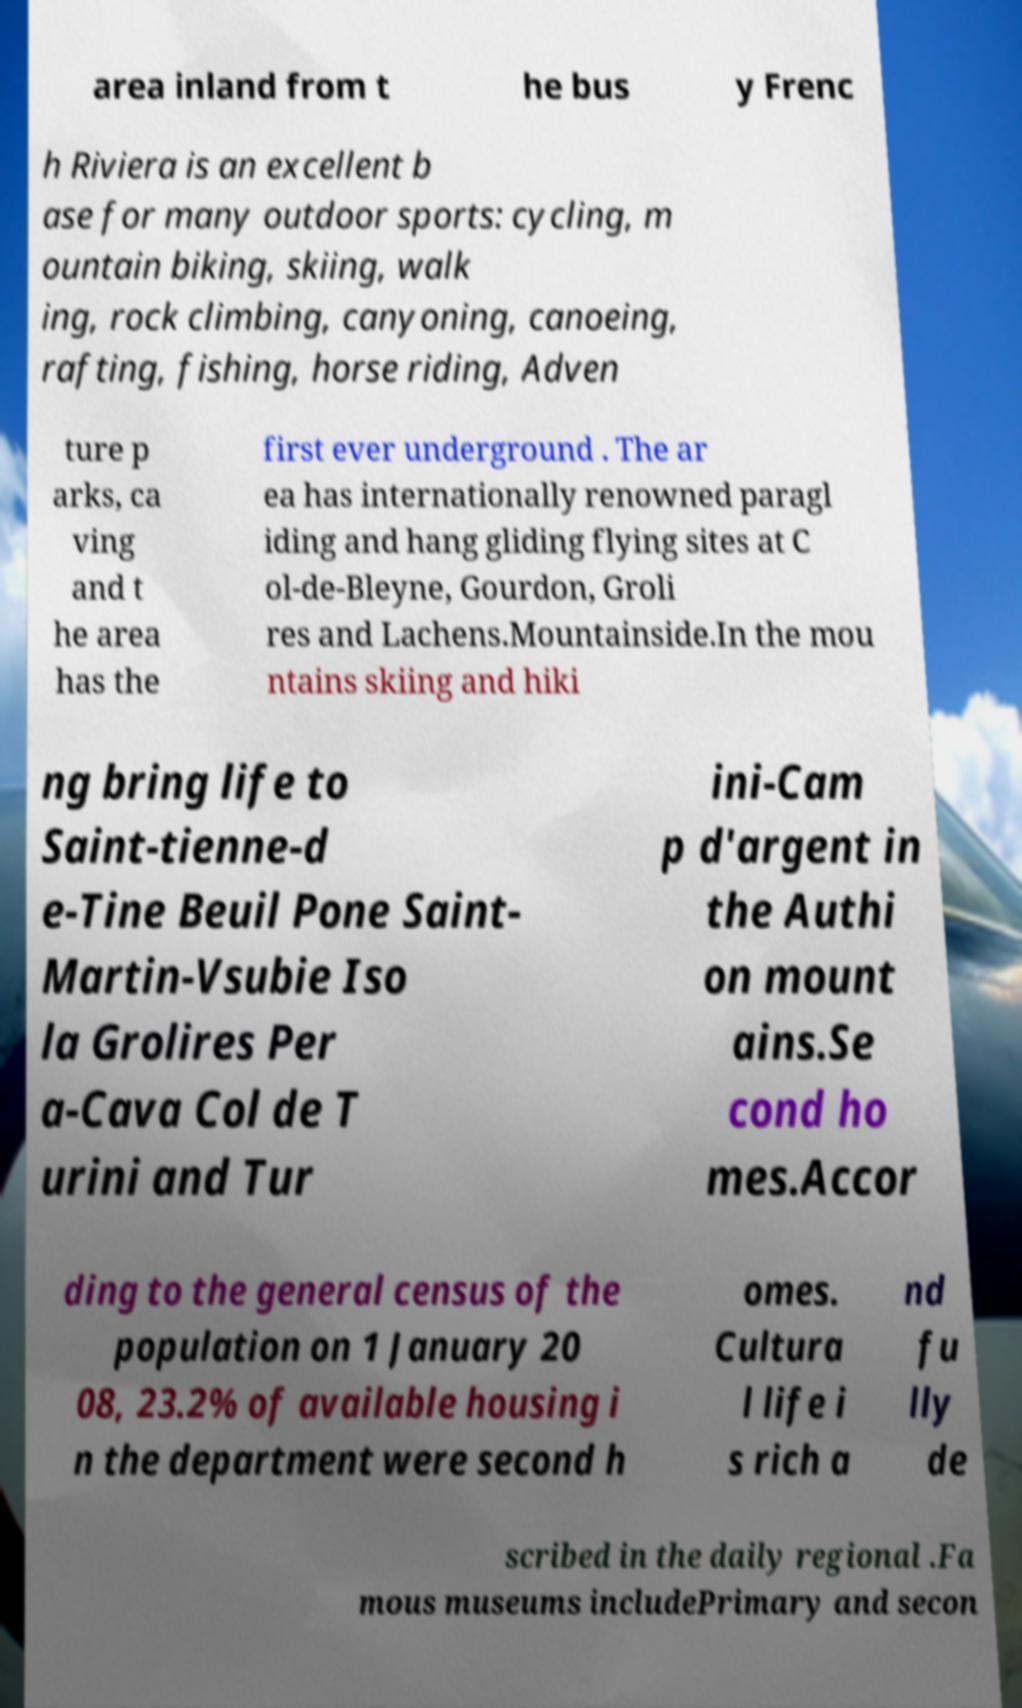Can you read and provide the text displayed in the image?This photo seems to have some interesting text. Can you extract and type it out for me? area inland from t he bus y Frenc h Riviera is an excellent b ase for many outdoor sports: cycling, m ountain biking, skiing, walk ing, rock climbing, canyoning, canoeing, rafting, fishing, horse riding, Adven ture p arks, ca ving and t he area has the first ever underground . The ar ea has internationally renowned paragl iding and hang gliding flying sites at C ol-de-Bleyne, Gourdon, Groli res and Lachens.Mountainside.In the mou ntains skiing and hiki ng bring life to Saint-tienne-d e-Tine Beuil Pone Saint- Martin-Vsubie Iso la Grolires Per a-Cava Col de T urini and Tur ini-Cam p d'argent in the Authi on mount ains.Se cond ho mes.Accor ding to the general census of the population on 1 January 20 08, 23.2% of available housing i n the department were second h omes. Cultura l life i s rich a nd fu lly de scribed in the daily regional .Fa mous museums includePrimary and secon 